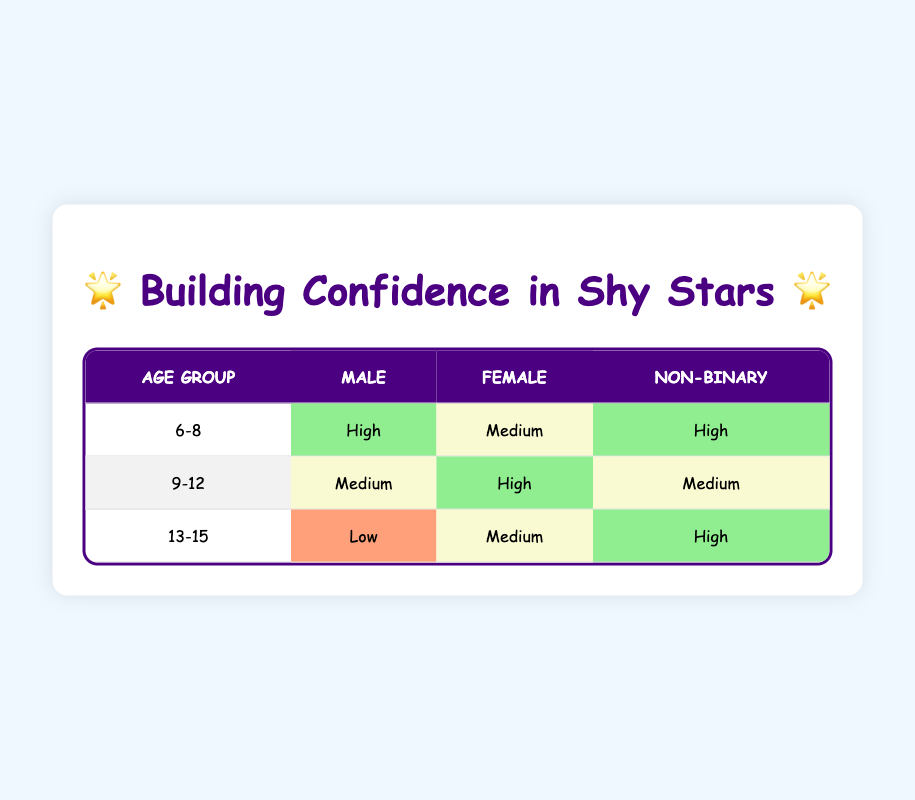What is the confidence increase for 6-8-year-old males? Looking at the table, under the age group 6-8, the confidence increase for males is categorized as "High".
Answer: High How many confidence increases are categorized as "Medium" for 9-12-year-olds? In the 9-12 age group, there are two instances categorized as "Medium": one for males and one for non-binary participants.
Answer: 2 Is there a confidence increase for 13-15-year-old females that is "Low"? The table shows that the confidence increase for 13-15-year-old females is "Medium", and there is no entry for "Low".
Answer: No What is the average confidence level for 6-8-year-old participants? In the 6-8 age group, we have two "High" and one "Medium". To find the average, we assign numerical values: High=3, Medium=2. So, (3 + 2 + 3)/3 = 8/3 which is approximately 2.67, indicating the average confidence level is leaning towards "High".
Answer: Approximately 2.67 (leaning towards High) How does the confidence increase for non-binary participants compare across age groups? For 6-8 year-olds, it's "High"; for 9-12 year-olds, it's "Medium"; and for 13-15 year-olds, it's also "High". This indicates that non-binary participants in both younger and older categories experience higher confidence increases compared to the middle category.
Answer: Non-binary participants have mixed increases, with highs at extremes and medium in the middle What percentage of participants aged 9-12 have "High" confidence increases? In the 9-12 age group, there are four participants: one male with "Medium", one female with "High", and one non-binary with "Medium". Only one out of four has "High", giving (1/4)*100 = 25%.
Answer: 25% Are any males aged 13-15 experiencing "High" confidence increases? The table states that the confidence increase for 13-15-year-old males is "Low", indicating that no males in this age group experience "High" confidence increases.
Answer: No What is the only confidence increase classification for non-binary participants in the 13-15-year-old group? In the 13-15 age group, the entry for non-binary participants states the confidence increase is "High," thus it is the only classification present for this group.
Answer: High How many total "High" confidence increases are reported across all age groups? On summing the "High" entries in the table: 2 from the 6-8 group (1 Male + 1 Non-Binary), 1 from the 9-12 group (1 Female), and 1 from the 13-15 group (1 Non-Binary), we find there are 4 total "High" entries overall.
Answer: 4 